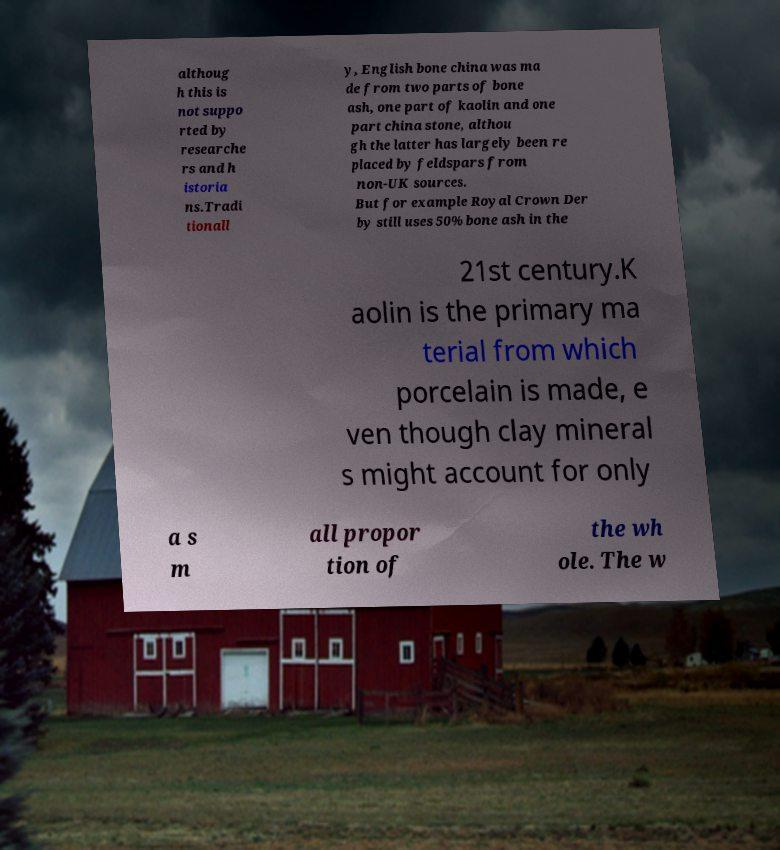What messages or text are displayed in this image? I need them in a readable, typed format. althoug h this is not suppo rted by researche rs and h istoria ns.Tradi tionall y, English bone china was ma de from two parts of bone ash, one part of kaolin and one part china stone, althou gh the latter has largely been re placed by feldspars from non-UK sources. But for example Royal Crown Der by still uses 50% bone ash in the 21st century.K aolin is the primary ma terial from which porcelain is made, e ven though clay mineral s might account for only a s m all propor tion of the wh ole. The w 